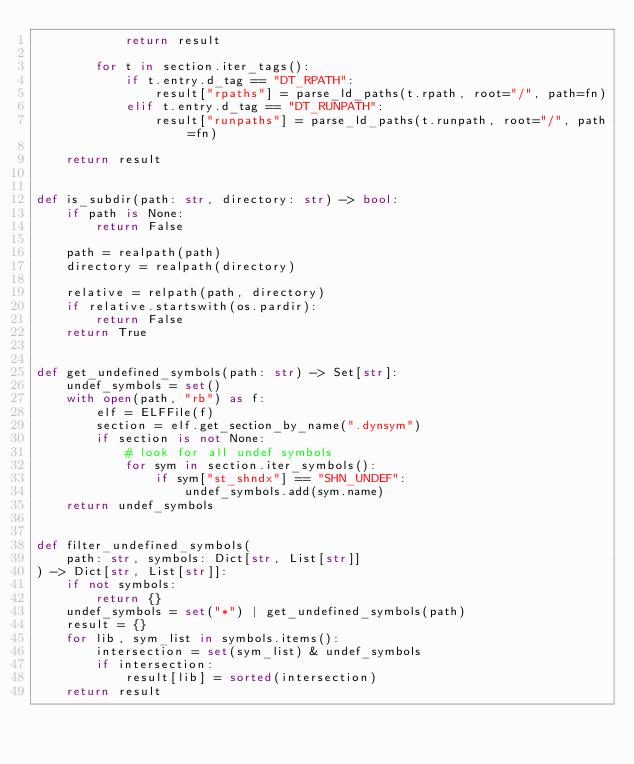<code> <loc_0><loc_0><loc_500><loc_500><_Python_>            return result

        for t in section.iter_tags():
            if t.entry.d_tag == "DT_RPATH":
                result["rpaths"] = parse_ld_paths(t.rpath, root="/", path=fn)
            elif t.entry.d_tag == "DT_RUNPATH":
                result["runpaths"] = parse_ld_paths(t.runpath, root="/", path=fn)

    return result


def is_subdir(path: str, directory: str) -> bool:
    if path is None:
        return False

    path = realpath(path)
    directory = realpath(directory)

    relative = relpath(path, directory)
    if relative.startswith(os.pardir):
        return False
    return True


def get_undefined_symbols(path: str) -> Set[str]:
    undef_symbols = set()
    with open(path, "rb") as f:
        elf = ELFFile(f)
        section = elf.get_section_by_name(".dynsym")
        if section is not None:
            # look for all undef symbols
            for sym in section.iter_symbols():
                if sym["st_shndx"] == "SHN_UNDEF":
                    undef_symbols.add(sym.name)
    return undef_symbols


def filter_undefined_symbols(
    path: str, symbols: Dict[str, List[str]]
) -> Dict[str, List[str]]:
    if not symbols:
        return {}
    undef_symbols = set("*") | get_undefined_symbols(path)
    result = {}
    for lib, sym_list in symbols.items():
        intersection = set(sym_list) & undef_symbols
        if intersection:
            result[lib] = sorted(intersection)
    return result
</code> 